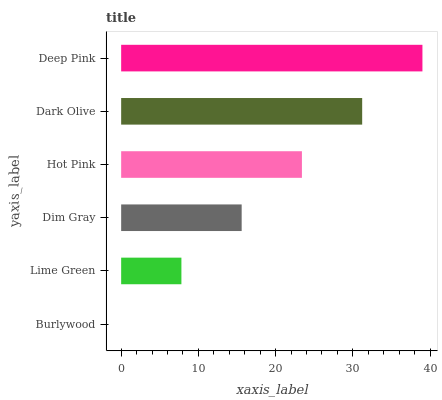Is Burlywood the minimum?
Answer yes or no. Yes. Is Deep Pink the maximum?
Answer yes or no. Yes. Is Lime Green the minimum?
Answer yes or no. No. Is Lime Green the maximum?
Answer yes or no. No. Is Lime Green greater than Burlywood?
Answer yes or no. Yes. Is Burlywood less than Lime Green?
Answer yes or no. Yes. Is Burlywood greater than Lime Green?
Answer yes or no. No. Is Lime Green less than Burlywood?
Answer yes or no. No. Is Hot Pink the high median?
Answer yes or no. Yes. Is Dim Gray the low median?
Answer yes or no. Yes. Is Lime Green the high median?
Answer yes or no. No. Is Dark Olive the low median?
Answer yes or no. No. 